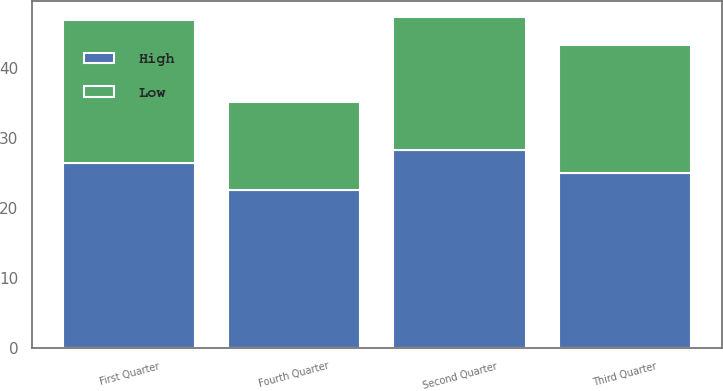Convert chart. <chart><loc_0><loc_0><loc_500><loc_500><stacked_bar_chart><ecel><fcel>First Quarter<fcel>Second Quarter<fcel>Third Quarter<fcel>Fourth Quarter<nl><fcel>High<fcel>26.41<fcel>28.18<fcel>25.01<fcel>22.5<nl><fcel>Low<fcel>20.33<fcel>19.01<fcel>18.27<fcel>12.61<nl></chart> 